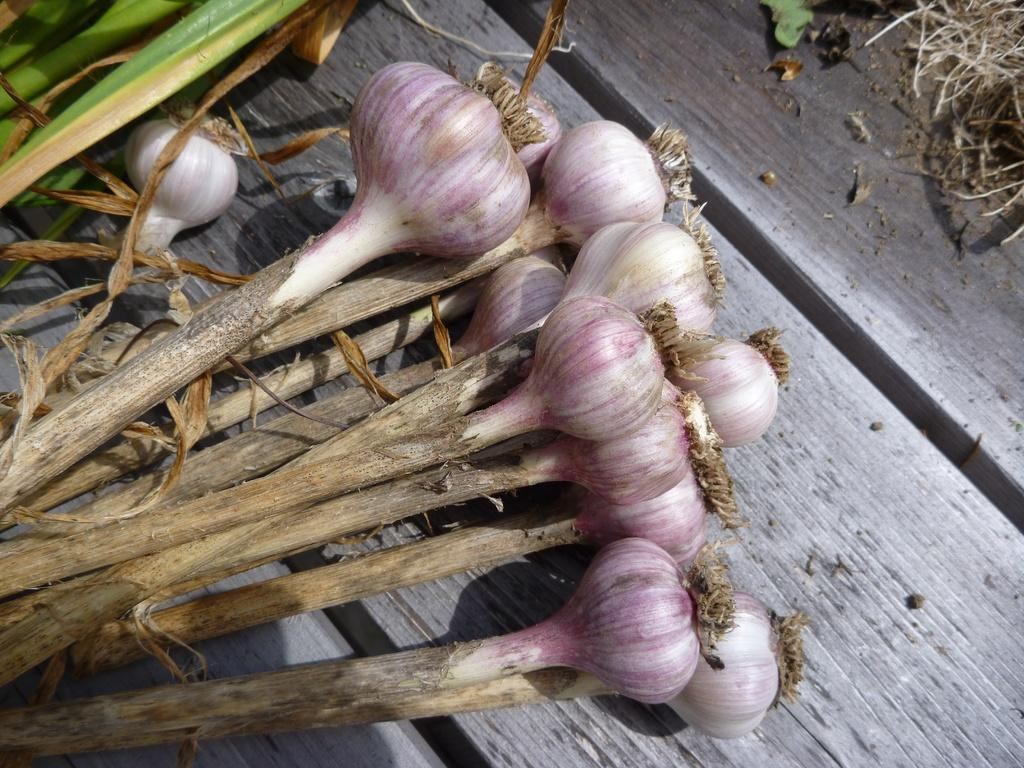What type of furniture is present in the image? There is a table in the image. Where is the table located in the image? The table is located at the bottom of the image. What items can be seen on the table? There are onions and plants on the table. What type of tin can be seen blowing in the wind on the table in the image? There is no tin present in the image, nor is there any wind blowing anything on the table. 